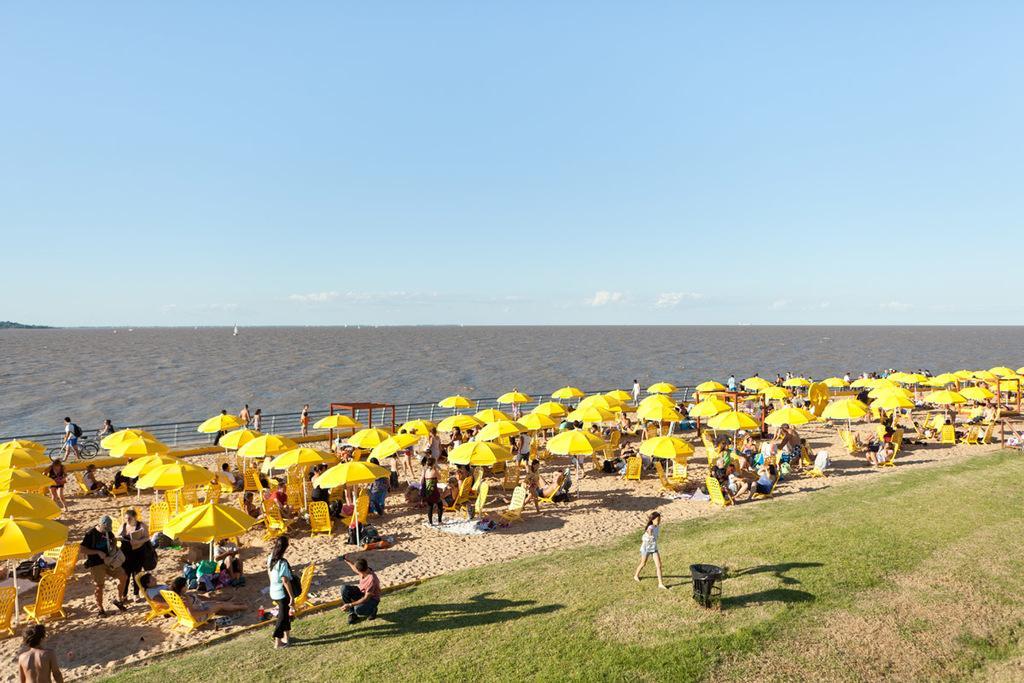In one or two sentences, can you explain what this image depicts? Here there are few persons sitting on the chairs under a tent on the stand and there are few people standing on the sand. There is a woman standing and a girl walking on the grass and there is a man in squat position on the grass. In the background we can see a fence,few persons,bicycle,water and clouds in the sky. 